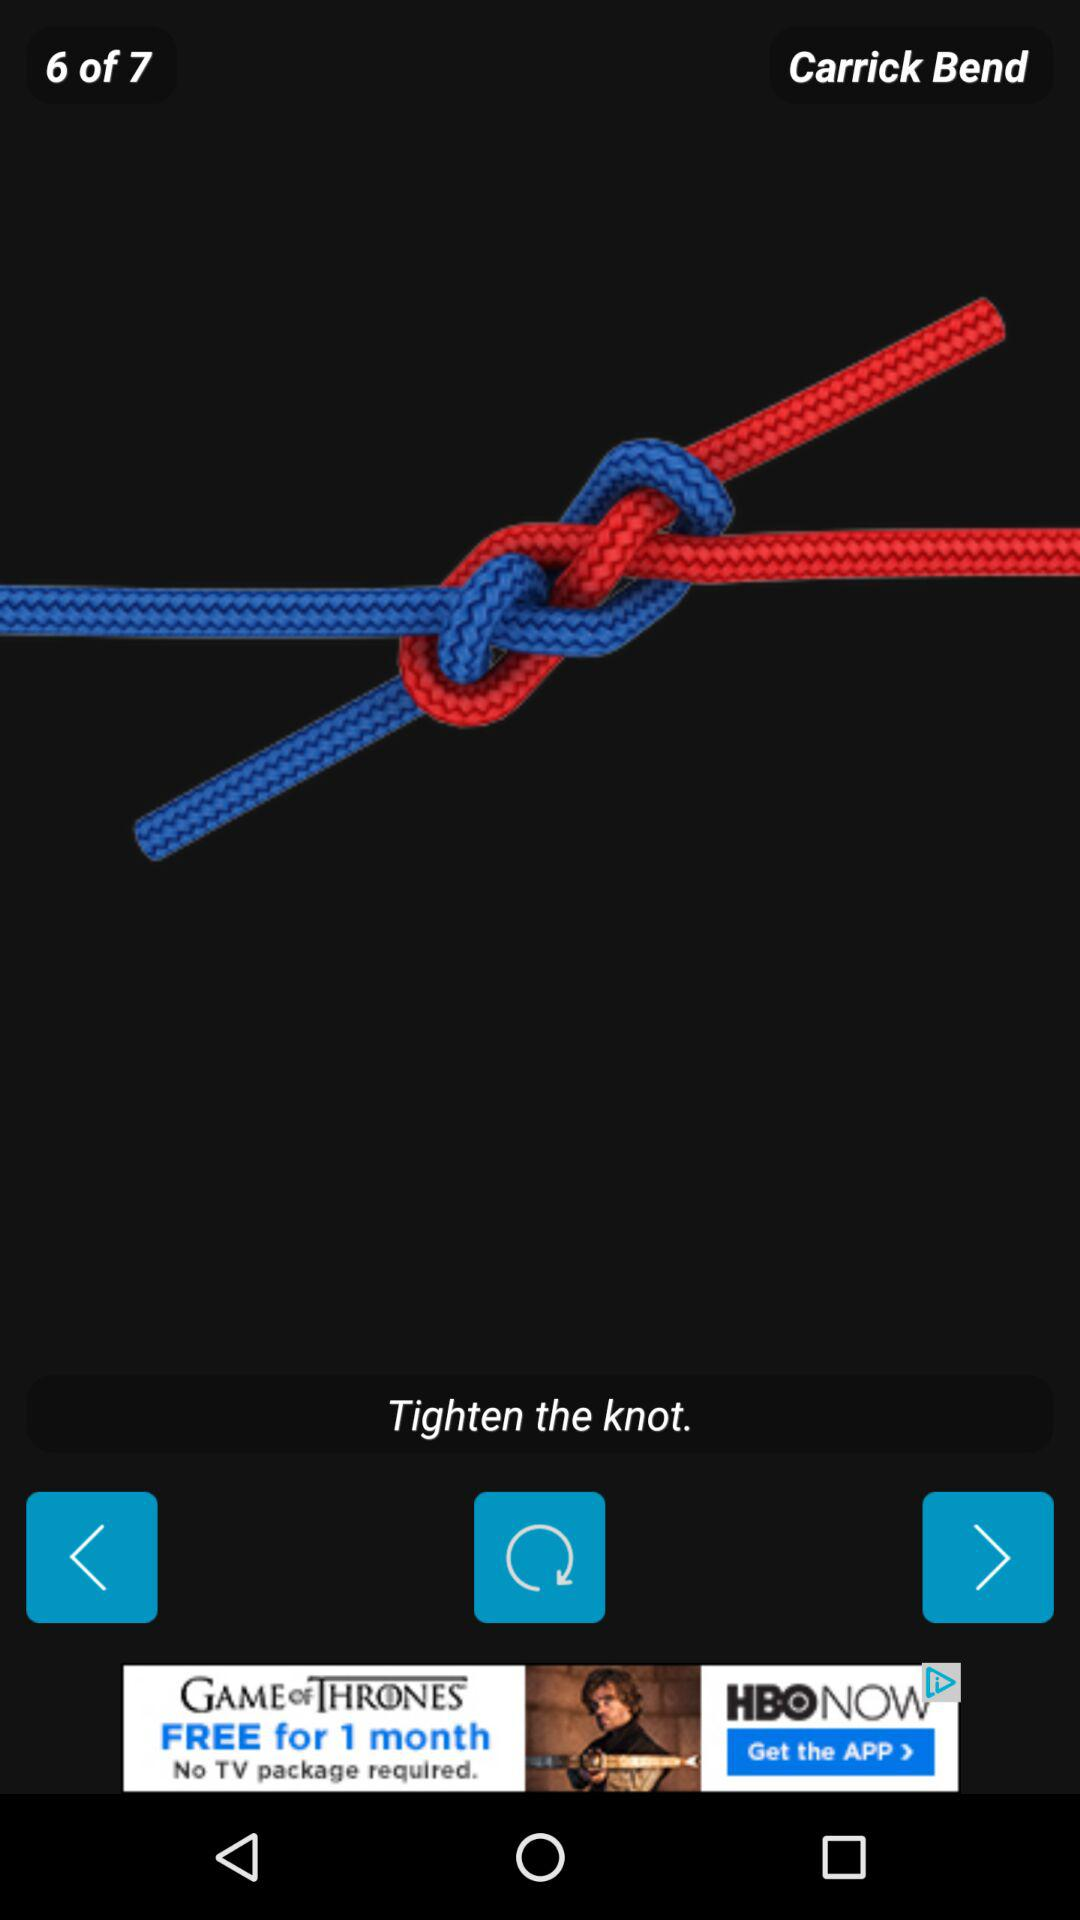What is the current bend number shown on the screen? The current bend number is six. 